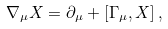<formula> <loc_0><loc_0><loc_500><loc_500>\nabla _ { \mu } X = \partial _ { \mu } + [ \Gamma _ { \mu } , X ] \, ,</formula> 